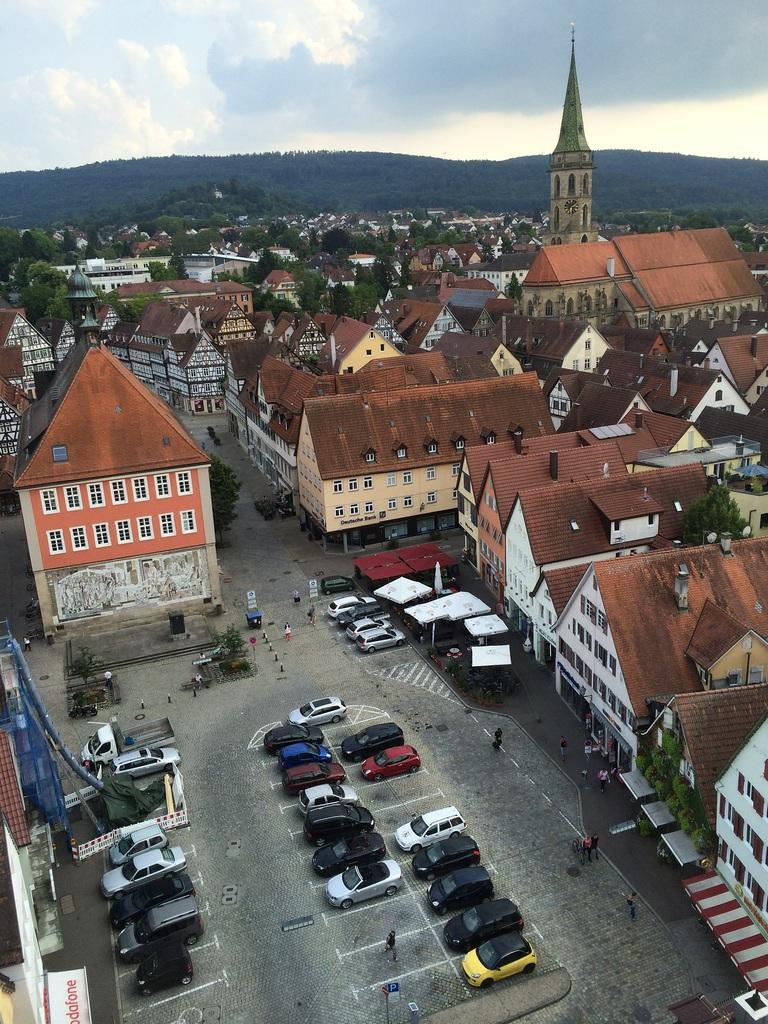What type of location is depicted in the image? The image is of a city. What mode of transportation can be seen in the image? There are cars in the image. What type of infrastructure is present in the image? There are roads and buildings in the image. What type of vegetation is present in the image? There are trees in the image. What type of temporary shelter is present in the image? There are tents in the image. What type of furniture is present in the image? There is a table in the image. What type of natural feature is visible in the background of the image? There are hills in the background of the image. What is the weather like in the image? The sky is cloudy in the image. What type of seat is visible in the image? There is no specific seat mentioned or visible in the image. What type of clothing item is hanging from the trees in the image? There are no clothing items hanging from the trees in the image. 